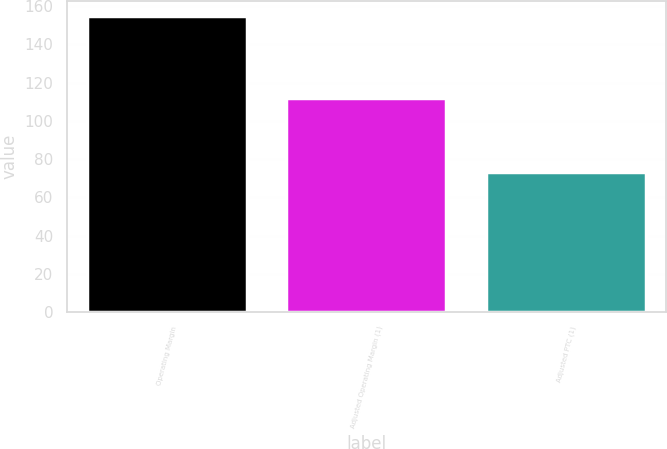Convert chart to OTSL. <chart><loc_0><loc_0><loc_500><loc_500><bar_chart><fcel>Operating Margin<fcel>Adjusted Operating Margin (1)<fcel>Adjusted PTC (1)<nl><fcel>155<fcel>112<fcel>73<nl></chart> 